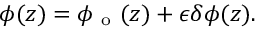Convert formula to latex. <formula><loc_0><loc_0><loc_500><loc_500>\phi ( z ) = \phi _ { o } ( z ) + \epsilon \delta \phi ( z ) .</formula> 